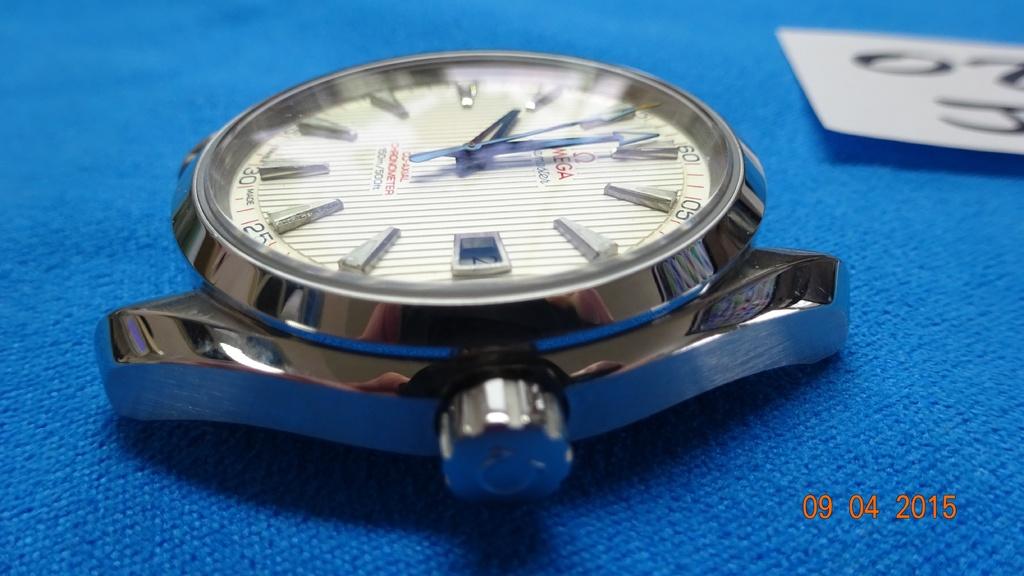What day was this photo taken?
Offer a very short reply. 09 04 2015. 